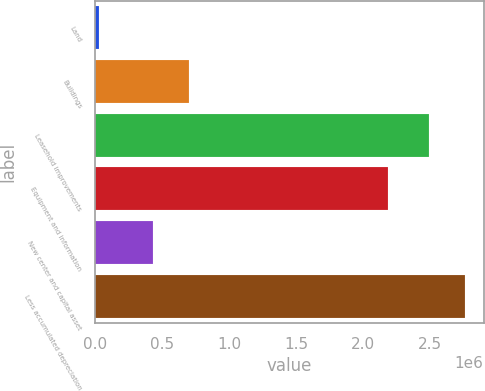Convert chart. <chart><loc_0><loc_0><loc_500><loc_500><bar_chart><fcel>Land<fcel>Buildings<fcel>Leasehold improvements<fcel>Equipment and information<fcel>New center and capital asset<fcel>Less accumulated depreciation<nl><fcel>26339<fcel>696231<fcel>2.49507e+06<fcel>2.18291e+06<fcel>429037<fcel>2.76226e+06<nl></chart> 